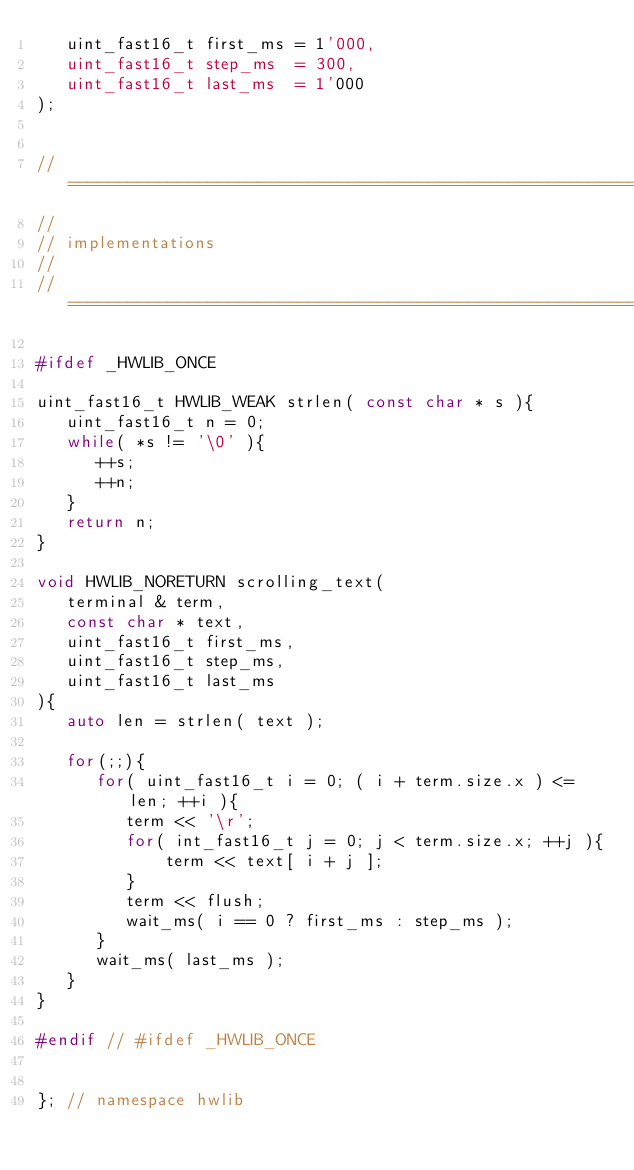Convert code to text. <code><loc_0><loc_0><loc_500><loc_500><_C++_>   uint_fast16_t first_ms = 1'000,
   uint_fast16_t step_ms  = 300,
   uint_fast16_t last_ms  = 1'000 
);


// ===========================================================================
//
// implementations
//
// ===========================================================================

#ifdef _HWLIB_ONCE 

uint_fast16_t HWLIB_WEAK strlen( const char * s ){
   uint_fast16_t n = 0;
   while( *s != '\0' ){
      ++s;
      ++n;
   }
   return n;
}

void HWLIB_NORETURN scrolling_text( 
   terminal & term, 
   const char * text, 
   uint_fast16_t first_ms,
   uint_fast16_t step_ms,
   uint_fast16_t last_ms
){
   auto len = strlen( text );
   
   for(;;){
      for( uint_fast16_t i = 0; ( i + term.size.x ) <= len; ++i ){
         term << '\r';
         for( int_fast16_t j = 0; j < term.size.x; ++j ){
			 term << text[ i + j ];
		 }
		 term << flush;
		 wait_ms( i == 0 ? first_ms : step_ms );
      }		 
      wait_ms( last_ms );
   }	   
}

#endif // #ifdef _HWLIB_ONCE


}; // namespace hwlib
</code> 